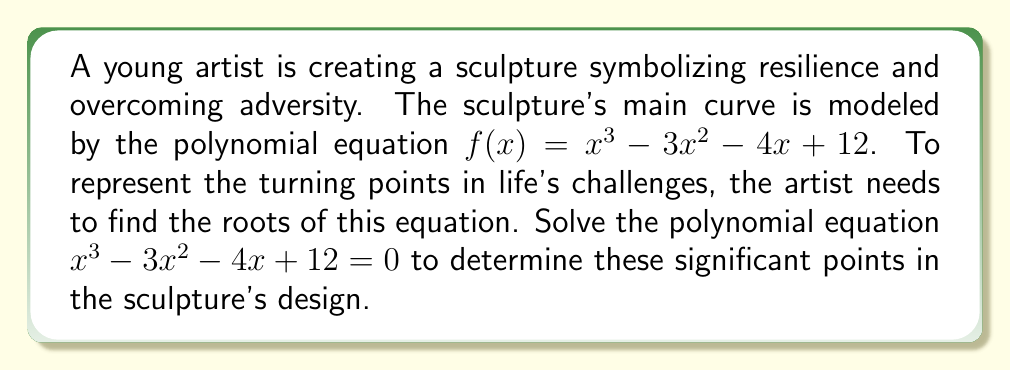Give your solution to this math problem. Let's solve this step-by-step using polynomial factorization:

1) First, we can try to guess one root. By inspection or trial and error, we can find that $x = 2$ is a root of the equation.

2) Using polynomial long division or the factor theorem, we can divide $f(x)$ by $(x - 2)$:

   $$f(x) = (x - 2)(x^2 - x - 6)$$

3) Now we need to solve the quadratic equation $x^2 - x - 6 = 0$

4) We can solve this using the quadratic formula: $x = \frac{-b \pm \sqrt{b^2 - 4ac}}{2a}$

   Where $a = 1$, $b = -1$, and $c = -6$

5) Substituting into the formula:

   $$x = \frac{1 \pm \sqrt{1 - 4(1)(-6)}}{2(1)} = \frac{1 \pm \sqrt{25}}{2} = \frac{1 \pm 5}{2}$$

6) This gives us two more roots:

   $$x = \frac{1 + 5}{2} = 3$$ and $$x = \frac{1 - 5}{2} = -2$$

7) Therefore, the three roots of the equation are $x = 2$, $x = 3$, and $x = -2$.

These roots represent the turning points in the sculpture's design, symbolizing key moments of change and resilience in overcoming adversity.
Answer: $x = -2, 2, 3$ 